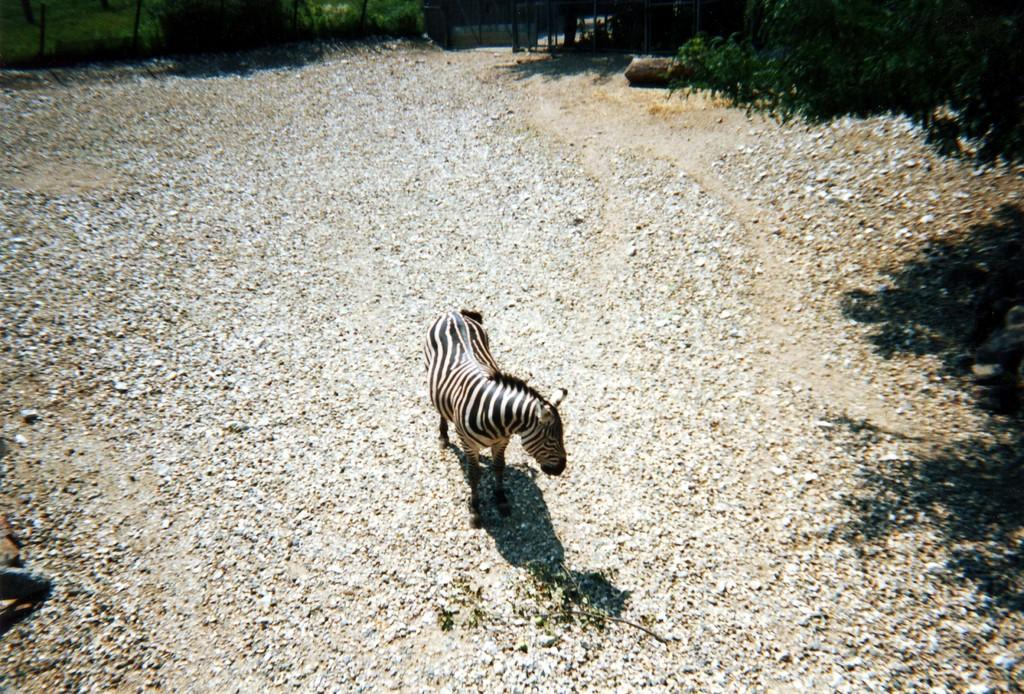What type of surface is visible in the image? There is a path filled with stones in the image. What animal is standing on the path? A zebra is standing on the path. What can be seen growing around the path? There are plants around the path. What structure is visible in the image? There is a wall visible in the image. What color is the butter on the zebra's elbow in the image? There is no butter or zebra's elbow present in the image. 